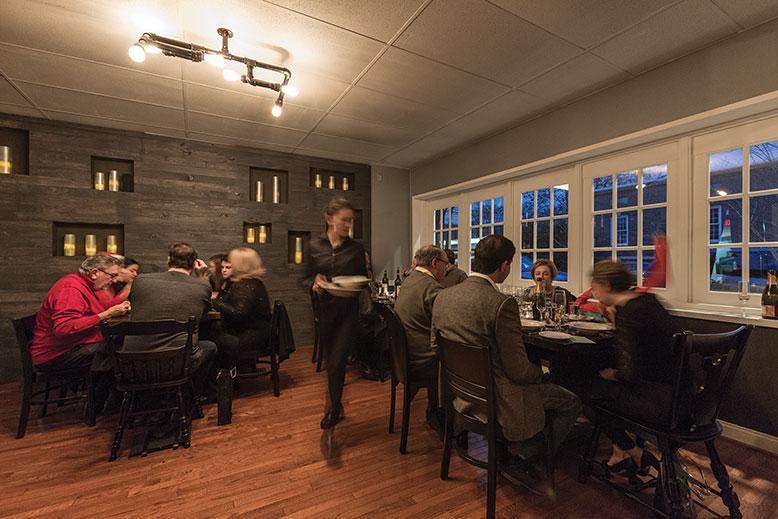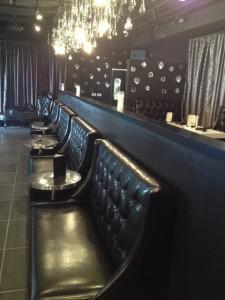The first image is the image on the left, the second image is the image on the right. For the images shown, is this caption "The right image shows a line of black benches with tufted backs in front of a low divider wall with a curtain behind it, and under lit hanging lights." true? Answer yes or no. Yes. The first image is the image on the left, the second image is the image on the right. Given the left and right images, does the statement "You can see barstools in one of the images." hold true? Answer yes or no. No. 